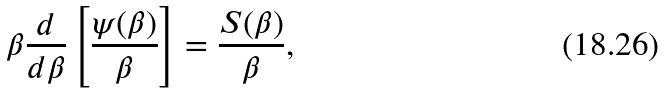<formula> <loc_0><loc_0><loc_500><loc_500>\beta \frac { d } { d \beta } \left [ \frac { \psi ( \beta ) } { \beta } \right ] = \frac { S ( \beta ) } { \beta } ,</formula> 